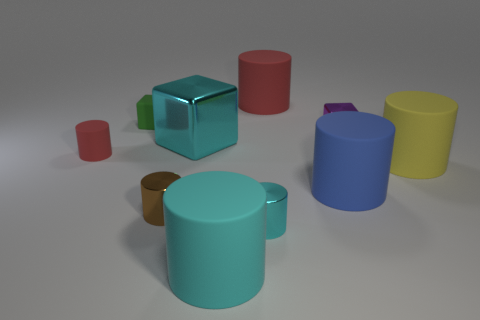Does the small green thing have the same shape as the yellow rubber object? The small green object is a cube, and it does not have the same shape as the yellow cylinder, despite both being similarly solid in appearance. 